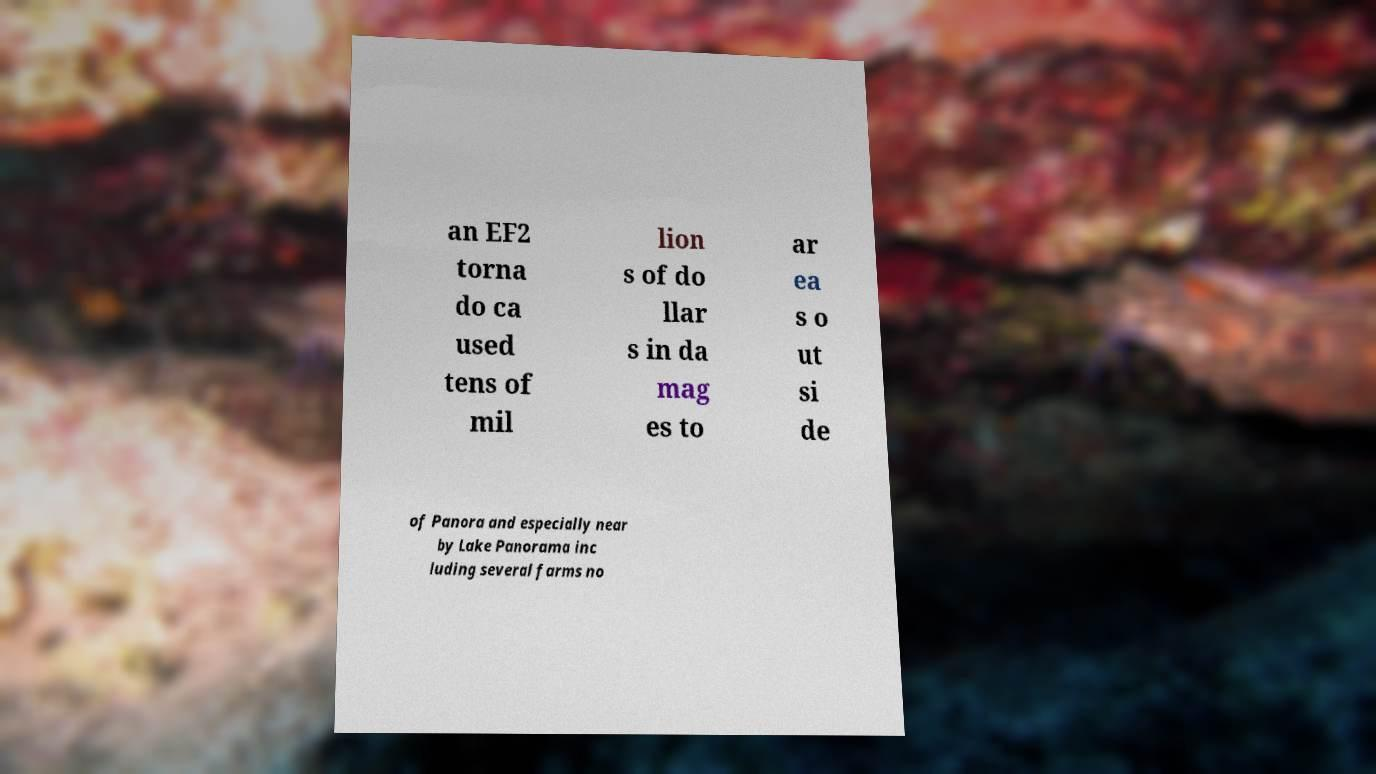What messages or text are displayed in this image? I need them in a readable, typed format. an EF2 torna do ca used tens of mil lion s of do llar s in da mag es to ar ea s o ut si de of Panora and especially near by Lake Panorama inc luding several farms no 